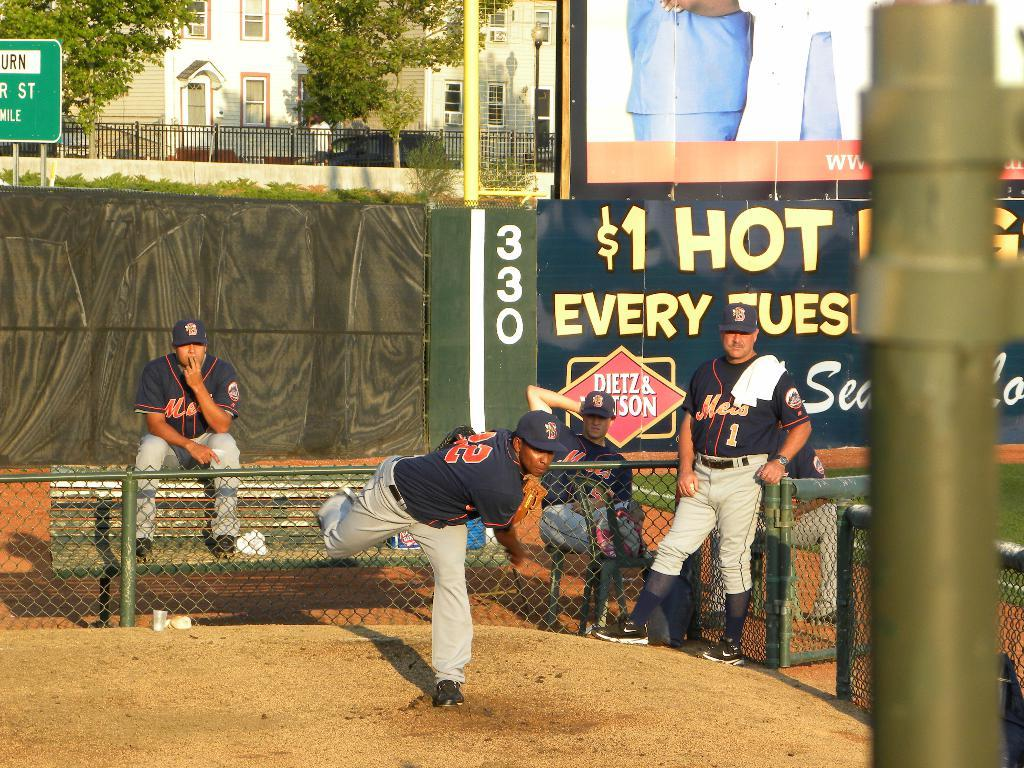<image>
Relay a brief, clear account of the picture shown. Several baseball players are standing or sitting in front of a sign that says $1 Hot Dog. 